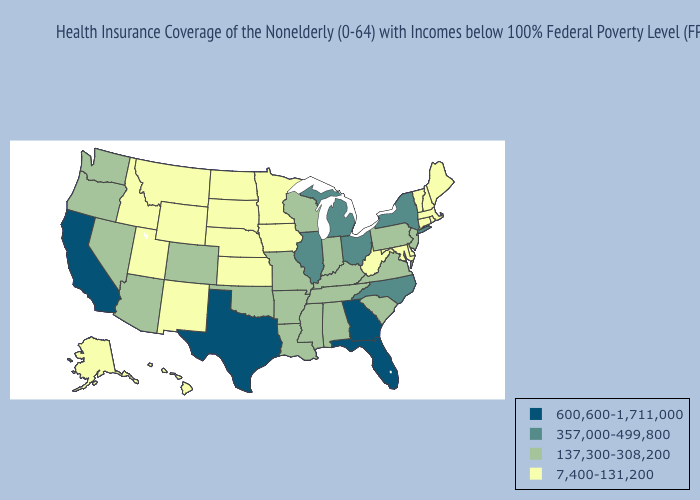What is the value of Washington?
Give a very brief answer. 137,300-308,200. Does Vermont have the lowest value in the USA?
Be succinct. Yes. Does Texas have the lowest value in the USA?
Quick response, please. No. Does Michigan have the lowest value in the USA?
Concise answer only. No. Which states have the highest value in the USA?
Write a very short answer. California, Florida, Georgia, Texas. How many symbols are there in the legend?
Short answer required. 4. Does Tennessee have the highest value in the South?
Give a very brief answer. No. What is the lowest value in the USA?
Write a very short answer. 7,400-131,200. How many symbols are there in the legend?
Keep it brief. 4. What is the value of New Jersey?
Quick response, please. 137,300-308,200. What is the highest value in the USA?
Be succinct. 600,600-1,711,000. Does Vermont have the lowest value in the Northeast?
Give a very brief answer. Yes. What is the value of Hawaii?
Short answer required. 7,400-131,200. What is the value of Arkansas?
Short answer required. 137,300-308,200. Is the legend a continuous bar?
Give a very brief answer. No. 